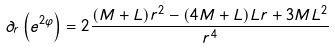Convert formula to latex. <formula><loc_0><loc_0><loc_500><loc_500>\partial _ { r } \left ( e ^ { 2 \varphi } \right ) = 2 \frac { ( M + L ) r ^ { 2 } - ( 4 M + L ) L r + 3 M L ^ { 2 } } { r ^ { 4 } }</formula> 